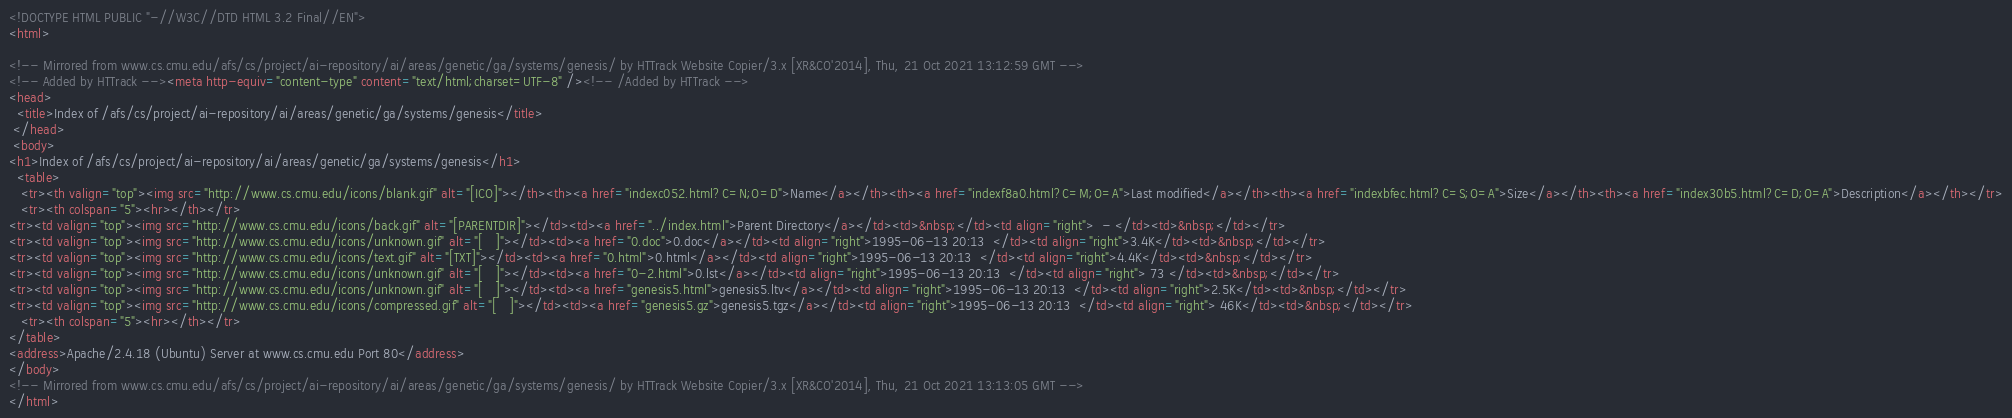Convert code to text. <code><loc_0><loc_0><loc_500><loc_500><_HTML_><!DOCTYPE HTML PUBLIC "-//W3C//DTD HTML 3.2 Final//EN">
<html>
 
<!-- Mirrored from www.cs.cmu.edu/afs/cs/project/ai-repository/ai/areas/genetic/ga/systems/genesis/ by HTTrack Website Copier/3.x [XR&CO'2014], Thu, 21 Oct 2021 13:12:59 GMT -->
<!-- Added by HTTrack --><meta http-equiv="content-type" content="text/html;charset=UTF-8" /><!-- /Added by HTTrack -->
<head>
  <title>Index of /afs/cs/project/ai-repository/ai/areas/genetic/ga/systems/genesis</title>
 </head>
 <body>
<h1>Index of /afs/cs/project/ai-repository/ai/areas/genetic/ga/systems/genesis</h1>
  <table>
   <tr><th valign="top"><img src="http://www.cs.cmu.edu/icons/blank.gif" alt="[ICO]"></th><th><a href="indexc052.html?C=N;O=D">Name</a></th><th><a href="indexf8a0.html?C=M;O=A">Last modified</a></th><th><a href="indexbfec.html?C=S;O=A">Size</a></th><th><a href="index30b5.html?C=D;O=A">Description</a></th></tr>
   <tr><th colspan="5"><hr></th></tr>
<tr><td valign="top"><img src="http://www.cs.cmu.edu/icons/back.gif" alt="[PARENTDIR]"></td><td><a href="../index.html">Parent Directory</a></td><td>&nbsp;</td><td align="right">  - </td><td>&nbsp;</td></tr>
<tr><td valign="top"><img src="http://www.cs.cmu.edu/icons/unknown.gif" alt="[   ]"></td><td><a href="0.doc">0.doc</a></td><td align="right">1995-06-13 20:13  </td><td align="right">3.4K</td><td>&nbsp;</td></tr>
<tr><td valign="top"><img src="http://www.cs.cmu.edu/icons/text.gif" alt="[TXT]"></td><td><a href="0.html">0.html</a></td><td align="right">1995-06-13 20:13  </td><td align="right">4.4K</td><td>&nbsp;</td></tr>
<tr><td valign="top"><img src="http://www.cs.cmu.edu/icons/unknown.gif" alt="[   ]"></td><td><a href="0-2.html">0.lst</a></td><td align="right">1995-06-13 20:13  </td><td align="right"> 73 </td><td>&nbsp;</td></tr>
<tr><td valign="top"><img src="http://www.cs.cmu.edu/icons/unknown.gif" alt="[   ]"></td><td><a href="genesis5.html">genesis5.ltv</a></td><td align="right">1995-06-13 20:13  </td><td align="right">2.5K</td><td>&nbsp;</td></tr>
<tr><td valign="top"><img src="http://www.cs.cmu.edu/icons/compressed.gif" alt="[   ]"></td><td><a href="genesis5.gz">genesis5.tgz</a></td><td align="right">1995-06-13 20:13  </td><td align="right"> 46K</td><td>&nbsp;</td></tr>
   <tr><th colspan="5"><hr></th></tr>
</table>
<address>Apache/2.4.18 (Ubuntu) Server at www.cs.cmu.edu Port 80</address>
</body>
<!-- Mirrored from www.cs.cmu.edu/afs/cs/project/ai-repository/ai/areas/genetic/ga/systems/genesis/ by HTTrack Website Copier/3.x [XR&CO'2014], Thu, 21 Oct 2021 13:13:05 GMT -->
</html>
</code> 